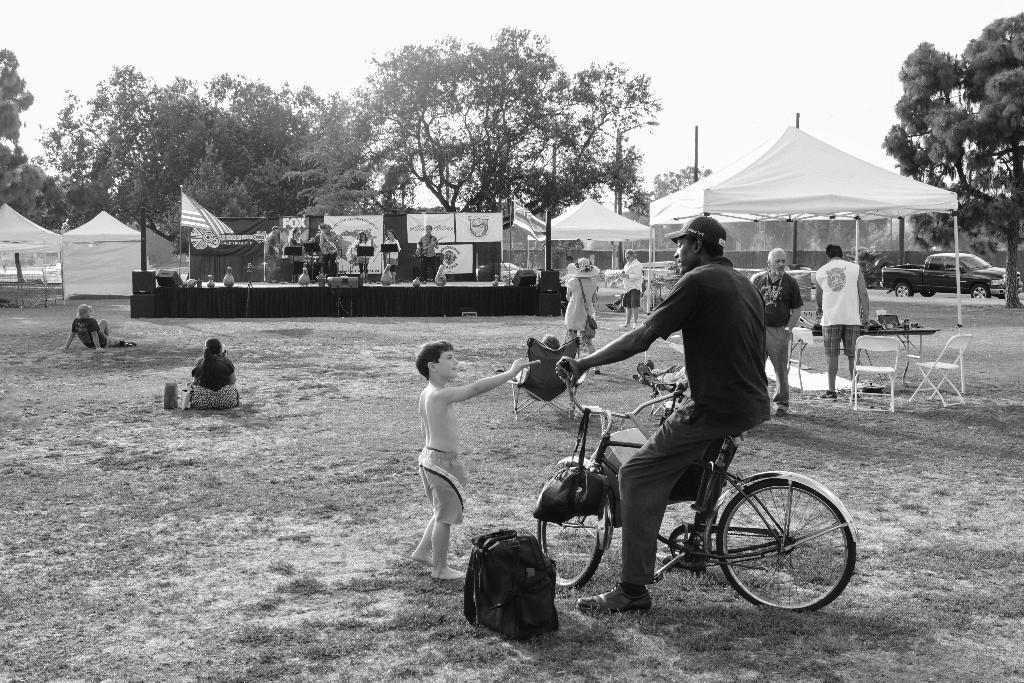In one or two sentences, can you explain what this image depicts? A man is sitting on the cycle beside it's a bag. In the middle there are trees,sky. 